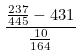Convert formula to latex. <formula><loc_0><loc_0><loc_500><loc_500>\frac { \frac { 2 3 7 } { 4 4 5 } - 4 3 1 } { \frac { 1 0 } { 1 6 4 } }</formula> 